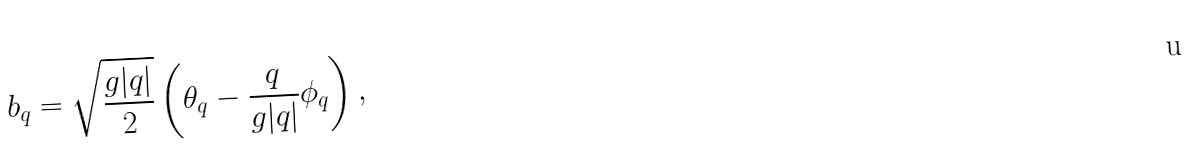Convert formula to latex. <formula><loc_0><loc_0><loc_500><loc_500>b _ { q } = \sqrt { \frac { g | q | } { 2 } } \left ( \theta _ { q } - \frac { q } { g | q | } \phi _ { q } \right ) ,</formula> 